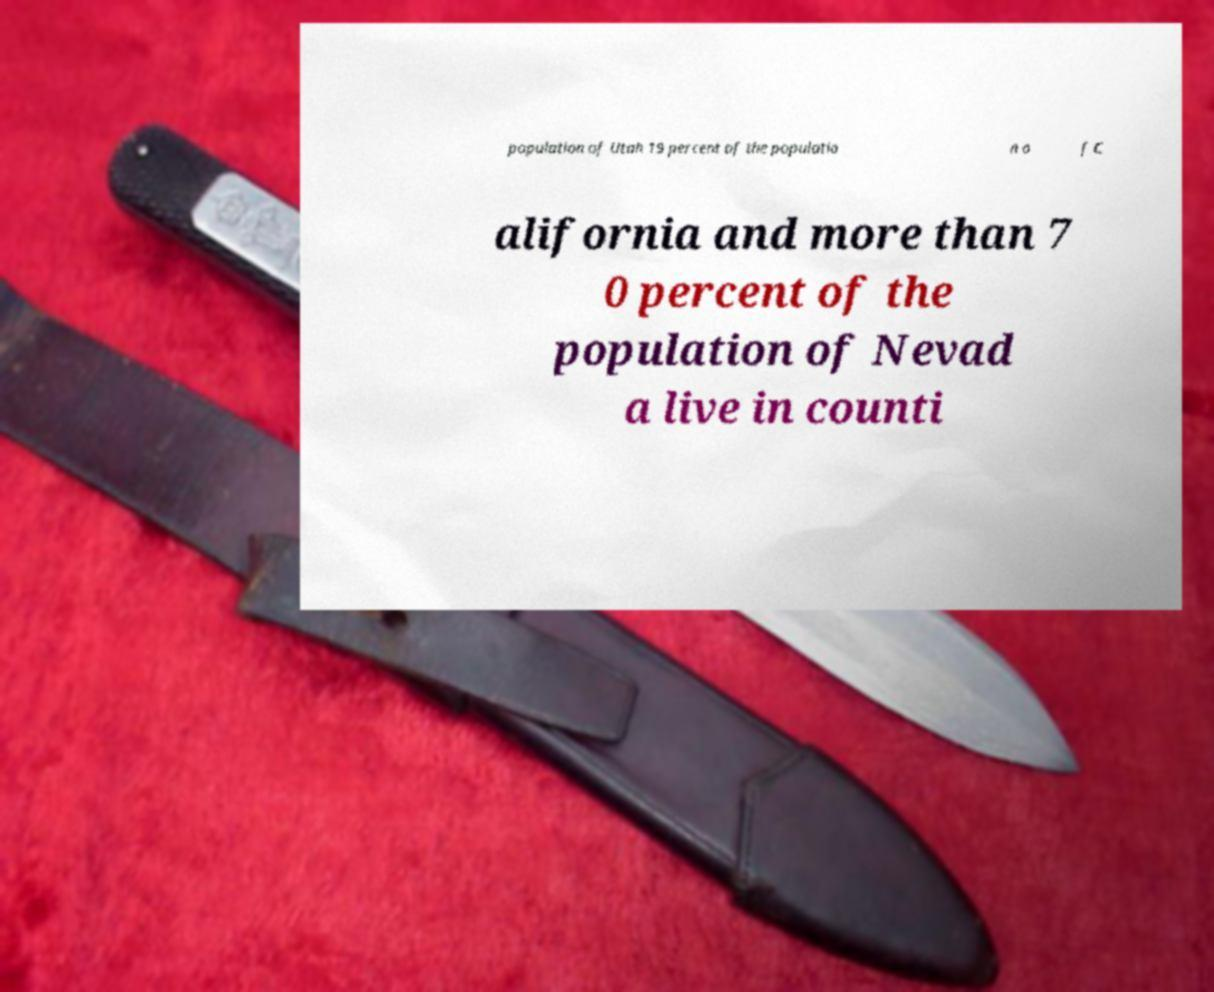I need the written content from this picture converted into text. Can you do that? population of Utah 19 percent of the populatio n o f C alifornia and more than 7 0 percent of the population of Nevad a live in counti 